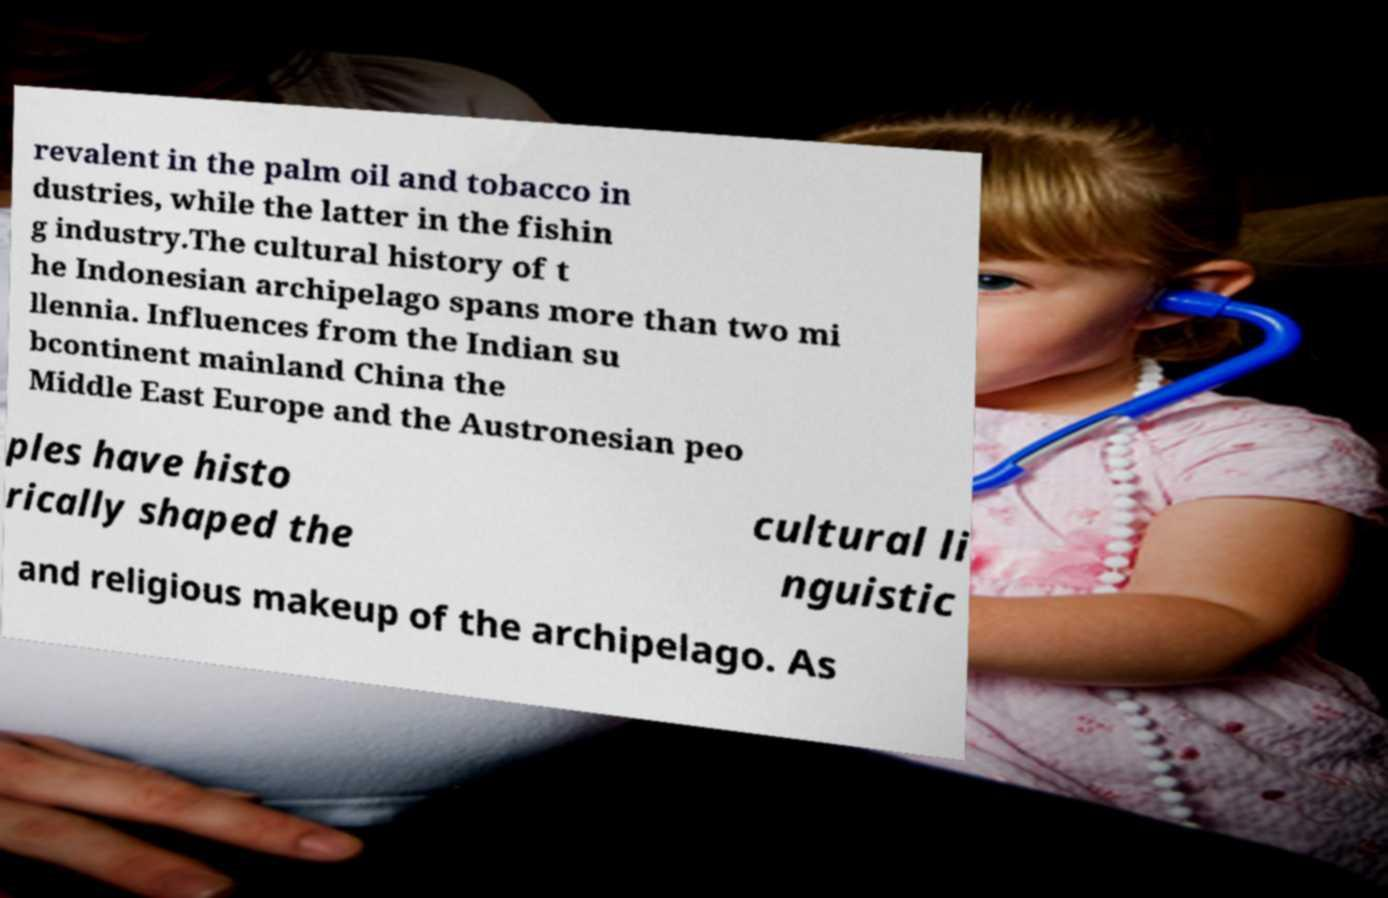Could you extract and type out the text from this image? revalent in the palm oil and tobacco in dustries, while the latter in the fishin g industry.The cultural history of t he Indonesian archipelago spans more than two mi llennia. Influences from the Indian su bcontinent mainland China the Middle East Europe and the Austronesian peo ples have histo rically shaped the cultural li nguistic and religious makeup of the archipelago. As 